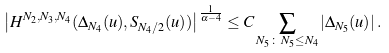<formula> <loc_0><loc_0><loc_500><loc_500>\left | H ^ { N _ { 2 } , N _ { 3 } , N _ { 4 } } ( \Delta _ { N _ { 4 } } ( u ) , S _ { N _ { 4 } / 2 } ( u ) ) \right | ^ { \frac { 1 } { \alpha - 4 } } \leq C \sum _ { N _ { 5 } \, \colon \, N _ { 5 } \leq N _ { 4 } } | \Delta _ { N _ { 5 } } ( u ) | \, .</formula> 